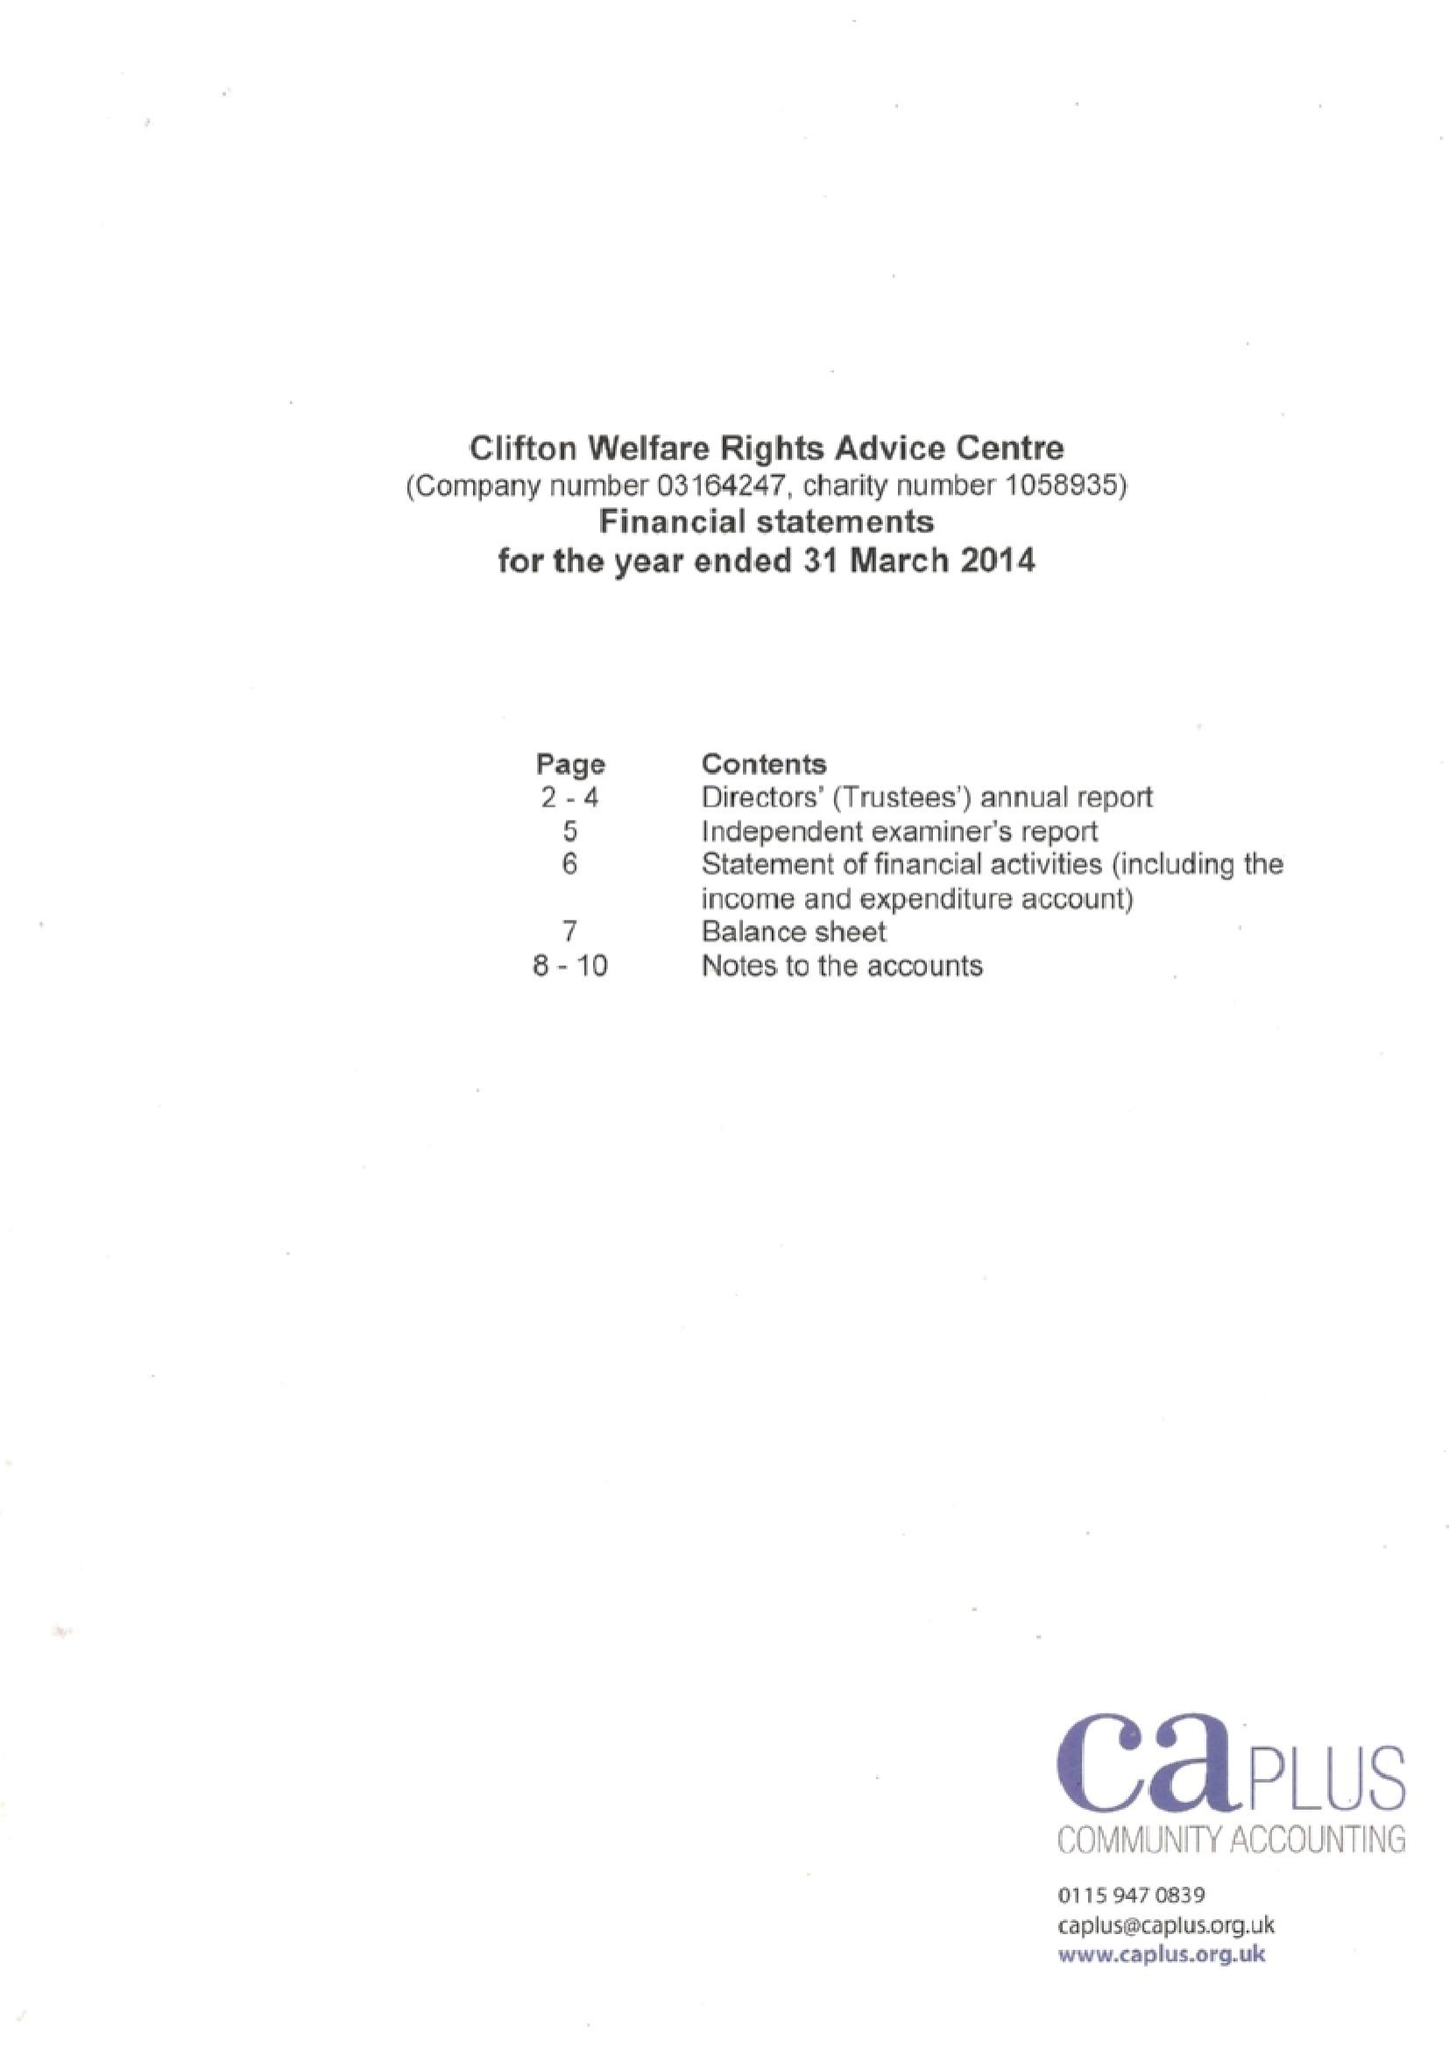What is the value for the income_annually_in_british_pounds?
Answer the question using a single word or phrase. 84769.00 